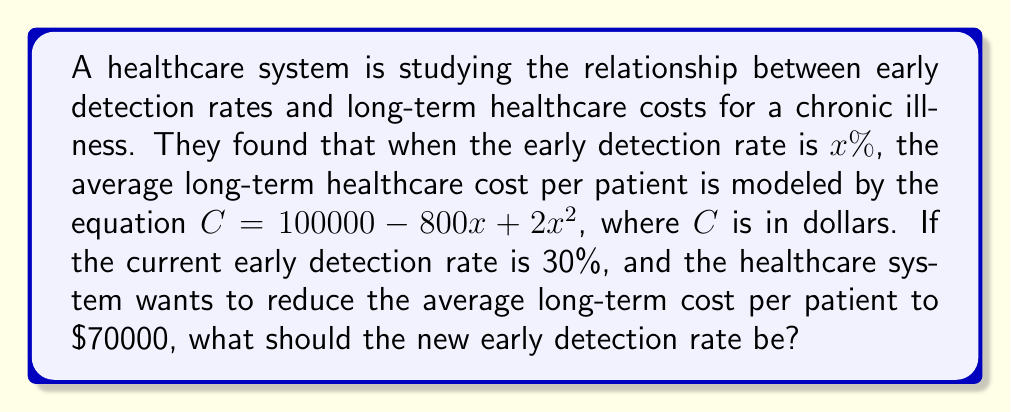Help me with this question. 1) We are given the equation $C = 100000 - 800x + 2x^2$, where $C$ is the cost in dollars and $x$ is the early detection rate as a percentage.

2) We want to find $x$ when $C = 70000$. Let's substitute these values into the equation:

   $70000 = 100000 - 800x + 2x^2$

3) Rearrange the equation:
   
   $2x^2 - 800x + 30000 = 0$

4) This is a quadratic equation. We can solve it using the quadratic formula:
   $x = \frac{-b \pm \sqrt{b^2 - 4ac}}{2a}$

   Where $a = 2$, $b = -800$, and $c = 30000$

5) Substituting these values:

   $x = \frac{800 \pm \sqrt{(-800)^2 - 4(2)(30000)}}{2(2)}$

6) Simplify:

   $x = \frac{800 \pm \sqrt{640000 - 240000}}{4} = \frac{800 \pm \sqrt{400000}}{4} = \frac{800 \pm 632.46}{4}$

7) This gives us two solutions:
   
   $x_1 = \frac{800 + 632.46}{4} = 358.12$
   $x_2 = \frac{800 - 632.46}{4} = 41.88$

8) Since we're looking for a new detection rate higher than the current 30%, we choose $x_2 = 41.88$.
Answer: 41.88% 